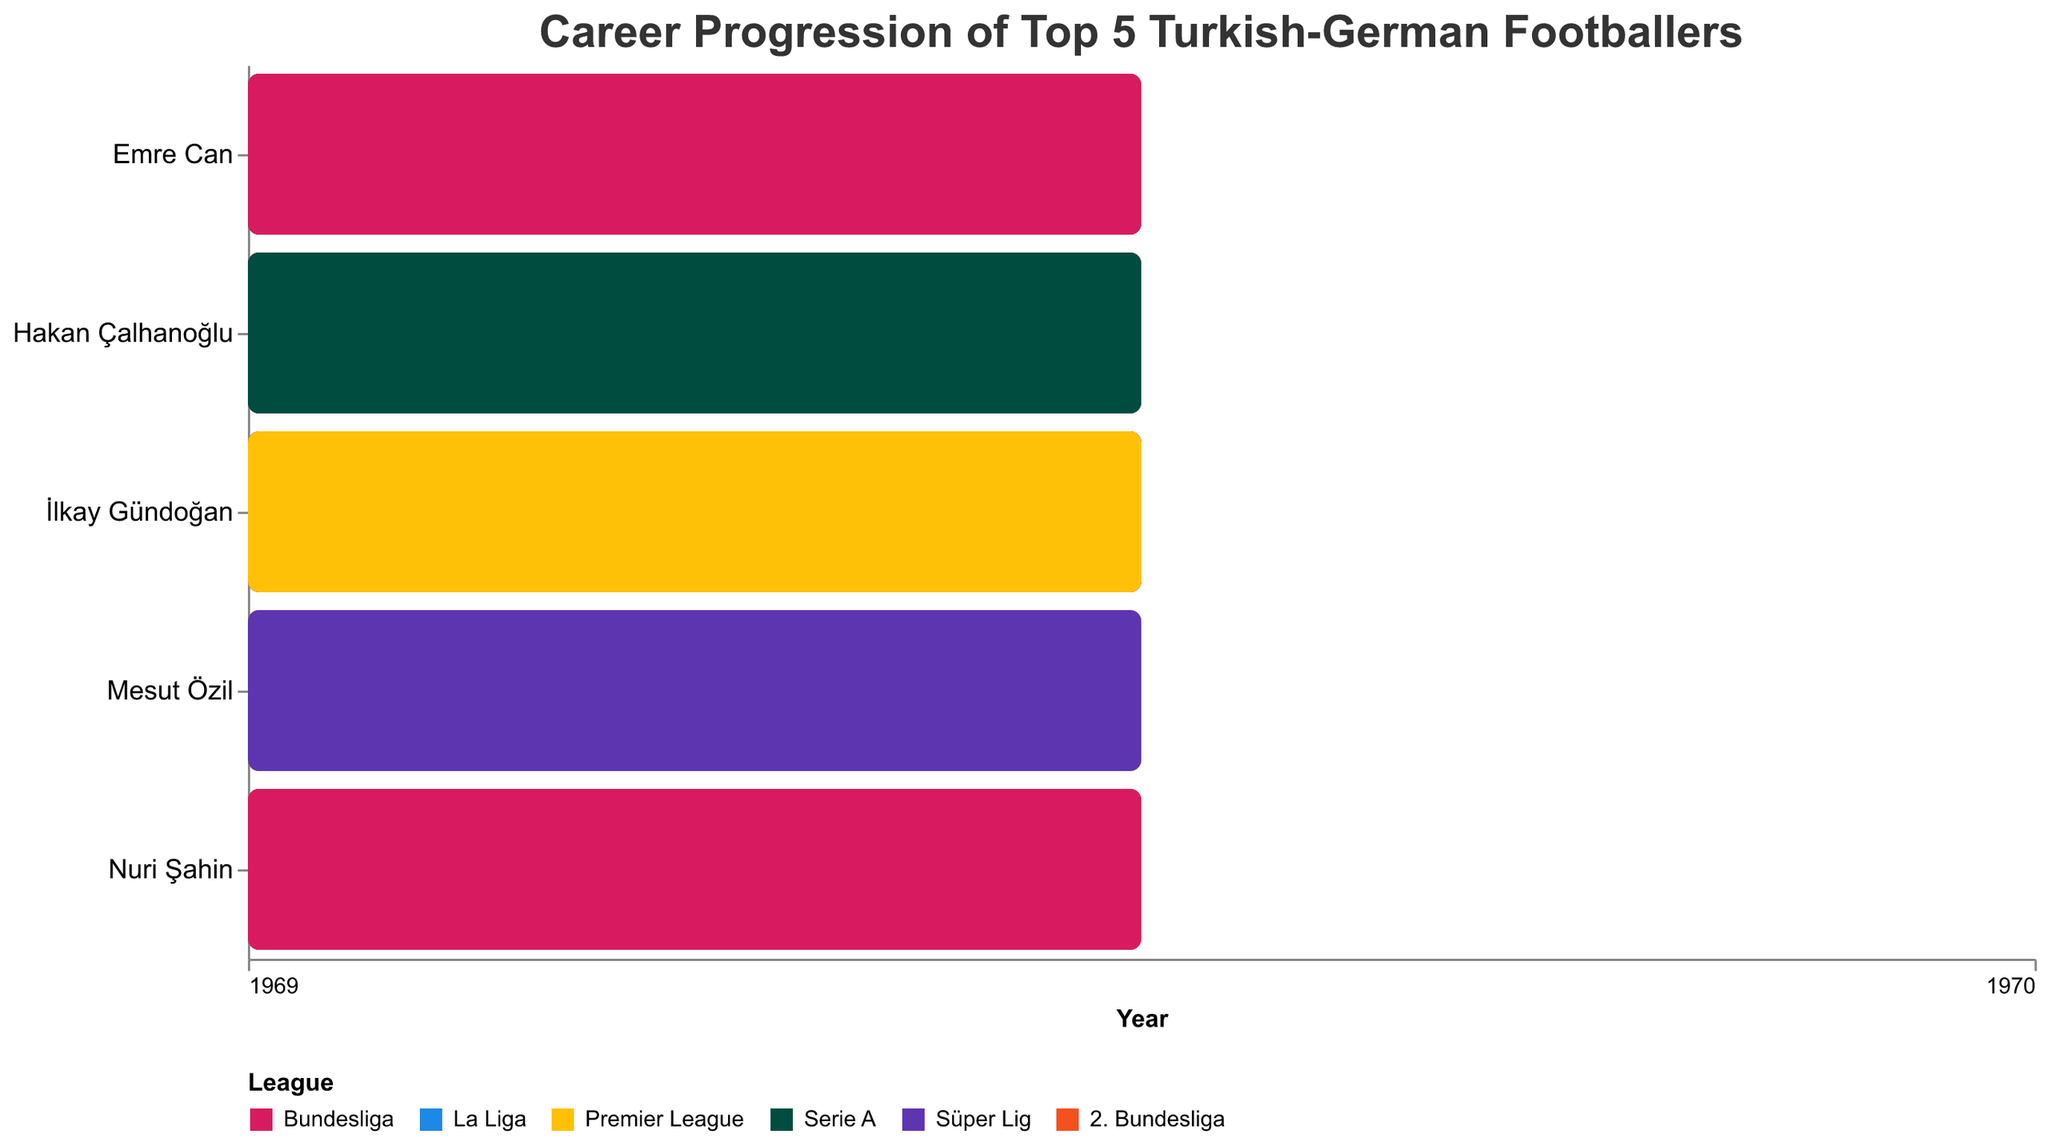What is the time span of Mesut Özil's career? Mesut Özil's career in the figure starts in 2006 with Schalke 04 and ends in 2022 with Fenerbahçe, making the time span 2006 to 2022.
Answer: 16 years Which footballer has the longest stint at a single club, and for how many years? Looking at the figure, Mesut Özil's longest stint is with Arsenal from 2013 to 2021, which is 8 years.
Answer: Mesut Özil (8 years) Which player moved to a new club most frequently? Emre Can played for five different clubs: Bayern Munich, Bayer Leverkusen, Liverpool, Juventus, and Borussia Dortmund. He moved the most frequently.
Answer: Emre Can How many players have played in both the Bundesliga and the Premier League? Mesut Özil, İlkay Gündoğan, Emre Can, and Nuri Şahin all played in both the Bundesliga and the Premier League. Four players in total.
Answer: 4 players Who started their professional career the earliest among the listed players? Nuri Şahin started his professional career with Borussia Dortmund in 2005, which is the earliest among the listed players.
Answer: Nuri Şahin Which leagues have Mesut Özil competed in during his career? Mesut Özil competed in the Bundesliga, La Liga, Premier League, and Süper Lig.
Answer: Bundesliga, La Liga, Premier League, Süper Lig How many years did İlkay Gündoğan play for Borussia Dortmund? He played for Borussia Dortmund from 2011 to 2016, which is 5 years.
Answer: 5 years Who has played in Serie A, and which clubs did they play for? Emre Can and Hakan Çalhanoğlu played in Serie A. Emre Can played for Juventus, and Hakan Çalhanoğlu played for AC Milan and Inter Milan.
Answer: Emre Can (Juventus), Hakan Çalhanoğlu (AC Milan, Inter Milan) Which player had the shortest tenure at a single club, and what was the duration? Emre Can at Bayern Munich from 2012 to 2013 was the shortest tenure, lasting just 1 year.
Answer: Emre Can (1 year) How many players have played for clubs in more than one major European league? Mesut Özil, İlkay Gündoğan, Emre Can, and Nuri Şahin have played in more than one major European league (e.g., Bundesliga, Premier League, La Liga, Serie A). A total of 4 players.
Answer: 4 players 